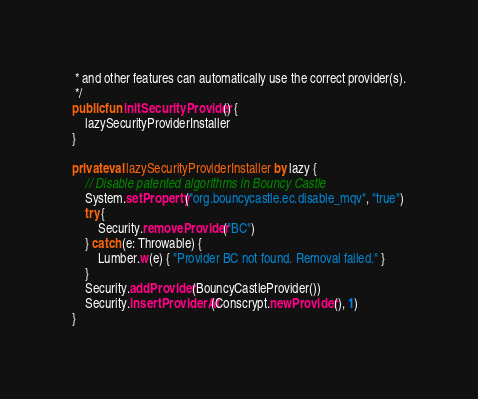<code> <loc_0><loc_0><loc_500><loc_500><_Kotlin_> * and other features can automatically use the correct provider(s).
 */
public fun initSecurityProvider() {
    lazySecurityProviderInstaller
}

private val lazySecurityProviderInstaller by lazy {
    // Disable patented algorithms in Bouncy Castle
    System.setProperty("org.bouncycastle.ec.disable_mqv", "true")
    try {
        Security.removeProvider("BC")
    } catch (e: Throwable) {
        Lumber.w(e) { "Provider BC not found. Removal failed." }
    }
    Security.addProvider(BouncyCastleProvider())
    Security.insertProviderAt(Conscrypt.newProvider(), 1)
}
</code> 